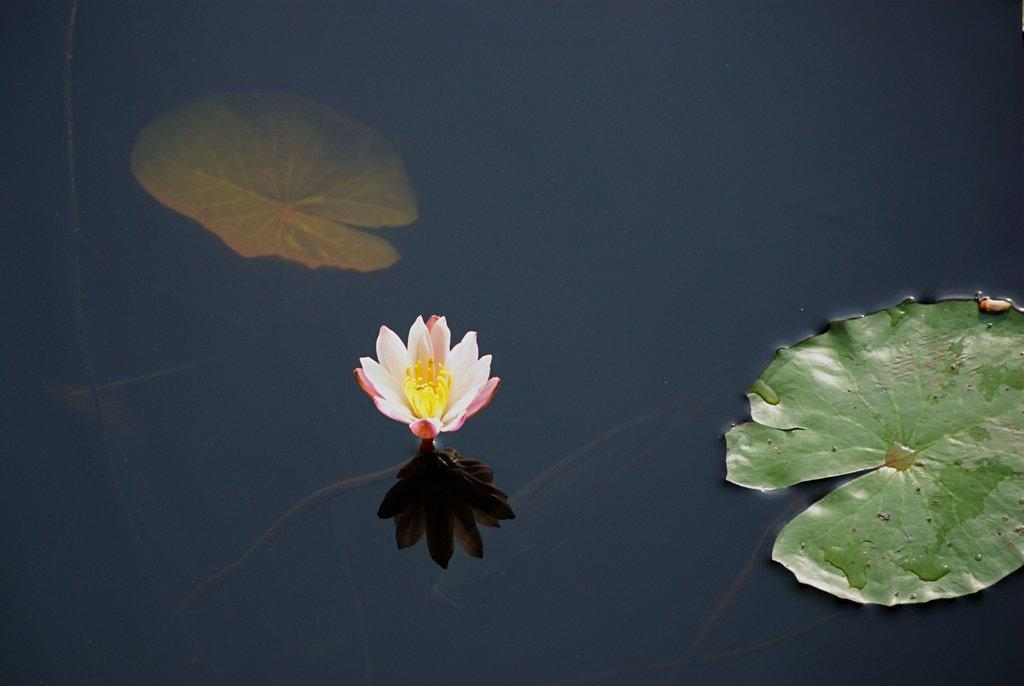What is the primary element visible in the image? There is water in the image. What is floating in the water? There is a leaf in the water, and there is also a leaf on the surface of the water. What other object can be seen on the surface of the water? There is a pink and yellow flower on the surface of the water. What type of amusement can be seen in the image? There is no amusement present in the image; it features water with leaves and a flower on its surface. What kind of test is being conducted in the image? There is no test being conducted in the image; it is a simple depiction of water with leaves and a flower. 